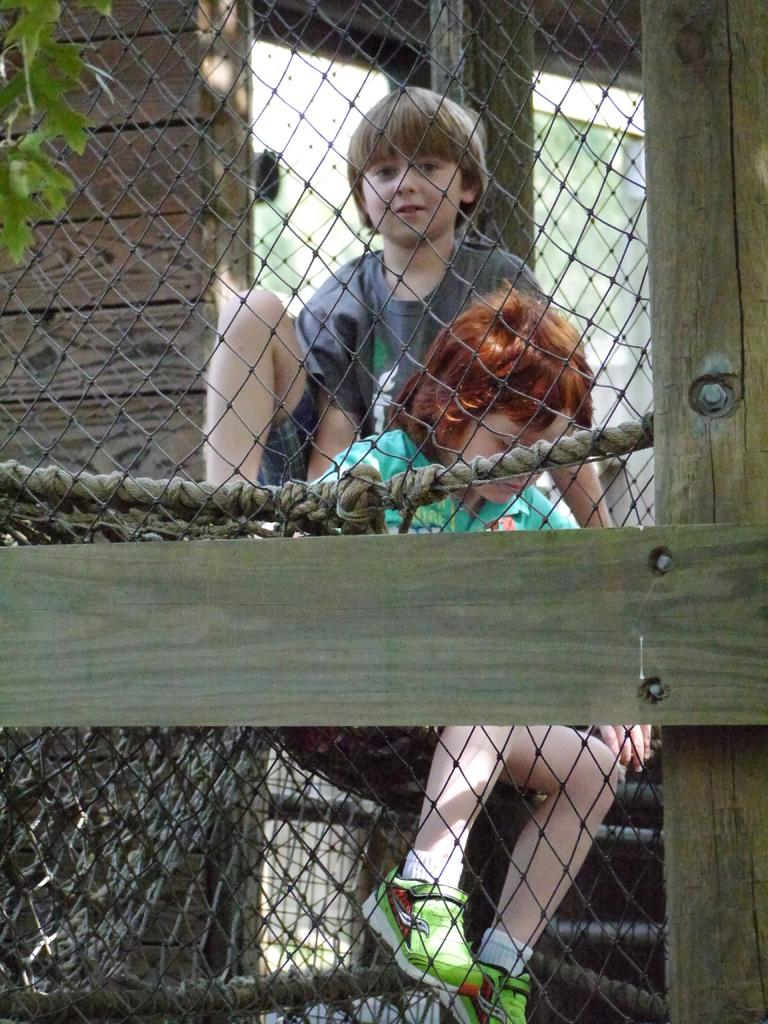How many kids are present in the image? There are two kids in the image. What are the kids attempting to do in the image? The kids are trying to get into a black color net. Can you describe any other structures or objects in the image? There is a wooden door visible in the image. What type of approval does the uncle give to the kids in the image? There is no uncle present in the image, so it is not possible to determine any approval given by an uncle. 